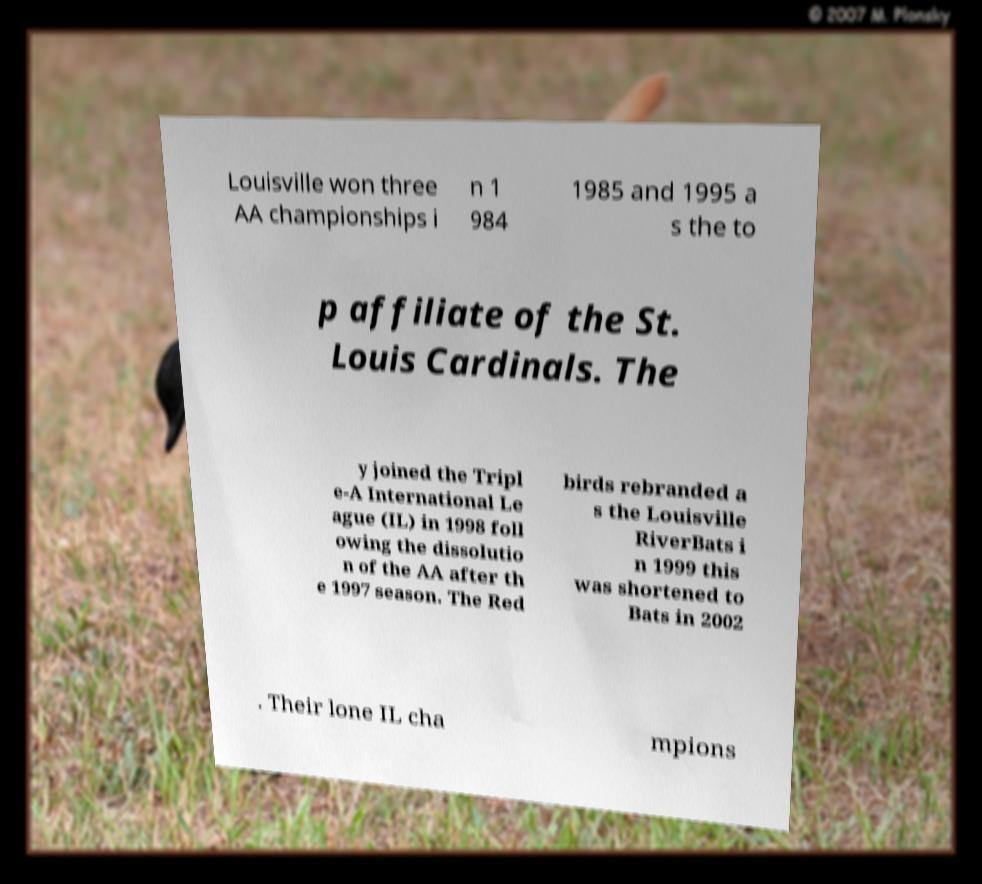Can you read and provide the text displayed in the image?This photo seems to have some interesting text. Can you extract and type it out for me? Louisville won three AA championships i n 1 984 1985 and 1995 a s the to p affiliate of the St. Louis Cardinals. The y joined the Tripl e-A International Le ague (IL) in 1998 foll owing the dissolutio n of the AA after th e 1997 season. The Red birds rebranded a s the Louisville RiverBats i n 1999 this was shortened to Bats in 2002 . Their lone IL cha mpions 